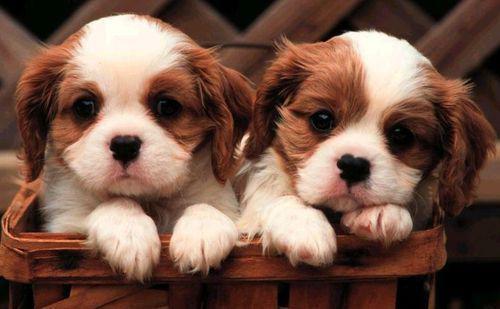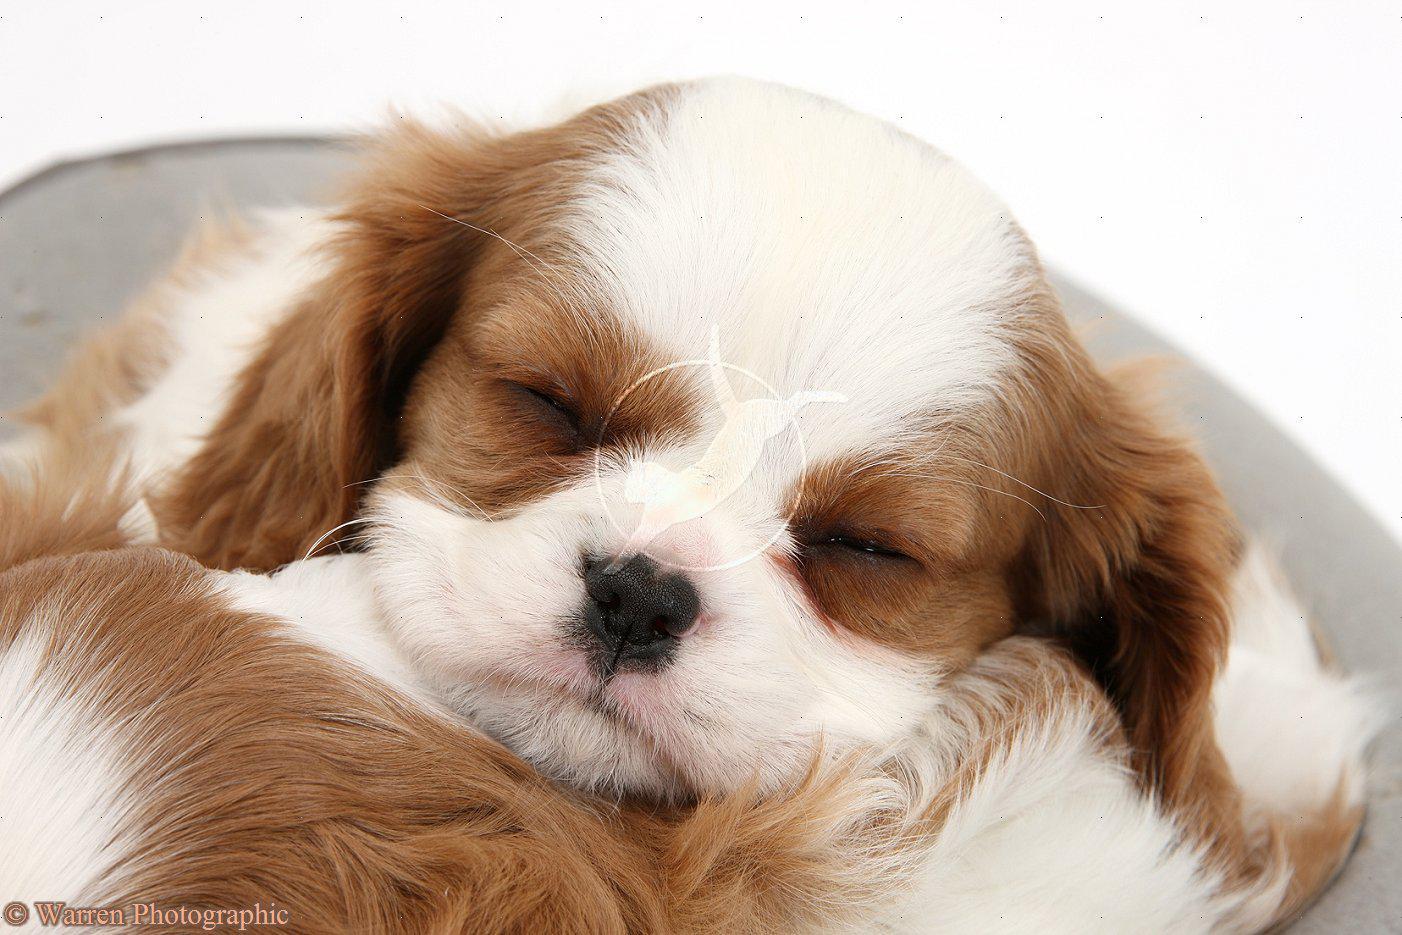The first image is the image on the left, the second image is the image on the right. Evaluate the accuracy of this statement regarding the images: "There are three dogs". Is it true? Answer yes or no. Yes. 